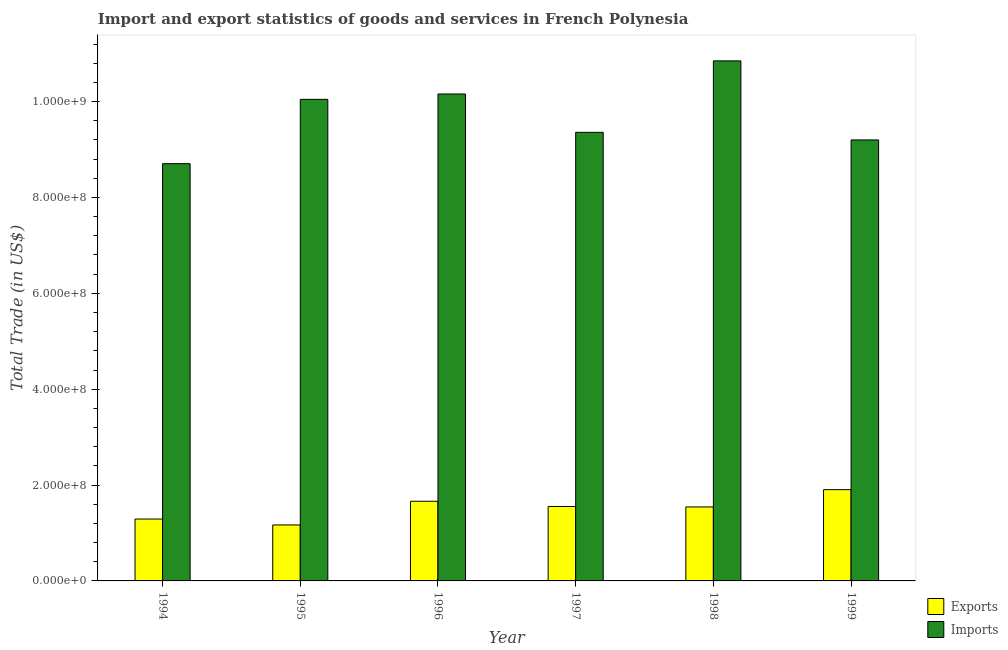How many bars are there on the 3rd tick from the left?
Make the answer very short. 2. What is the export of goods and services in 1996?
Give a very brief answer. 1.66e+08. Across all years, what is the maximum imports of goods and services?
Provide a short and direct response. 1.08e+09. Across all years, what is the minimum imports of goods and services?
Offer a very short reply. 8.70e+08. In which year was the export of goods and services minimum?
Your answer should be very brief. 1995. What is the total export of goods and services in the graph?
Offer a terse response. 9.12e+08. What is the difference between the export of goods and services in 1995 and that in 1999?
Make the answer very short. -7.37e+07. What is the difference between the imports of goods and services in 1995 and the export of goods and services in 1999?
Your answer should be very brief. 8.47e+07. What is the average export of goods and services per year?
Offer a very short reply. 1.52e+08. In the year 1996, what is the difference between the imports of goods and services and export of goods and services?
Offer a very short reply. 0. What is the ratio of the imports of goods and services in 1995 to that in 1998?
Ensure brevity in your answer.  0.93. What is the difference between the highest and the second highest imports of goods and services?
Make the answer very short. 6.91e+07. What is the difference between the highest and the lowest imports of goods and services?
Your answer should be compact. 2.14e+08. In how many years, is the imports of goods and services greater than the average imports of goods and services taken over all years?
Offer a very short reply. 3. Is the sum of the imports of goods and services in 1994 and 1997 greater than the maximum export of goods and services across all years?
Your answer should be compact. Yes. What does the 2nd bar from the left in 1996 represents?
Offer a very short reply. Imports. What does the 2nd bar from the right in 1995 represents?
Offer a very short reply. Exports. Are all the bars in the graph horizontal?
Offer a terse response. No. What is the difference between two consecutive major ticks on the Y-axis?
Make the answer very short. 2.00e+08. Does the graph contain any zero values?
Provide a succinct answer. No. Does the graph contain grids?
Your answer should be very brief. No. Where does the legend appear in the graph?
Give a very brief answer. Bottom right. How many legend labels are there?
Offer a very short reply. 2. How are the legend labels stacked?
Your answer should be very brief. Vertical. What is the title of the graph?
Provide a succinct answer. Import and export statistics of goods and services in French Polynesia. Does "Arms imports" appear as one of the legend labels in the graph?
Your response must be concise. No. What is the label or title of the Y-axis?
Offer a very short reply. Total Trade (in US$). What is the Total Trade (in US$) in Exports in 1994?
Ensure brevity in your answer.  1.29e+08. What is the Total Trade (in US$) in Imports in 1994?
Keep it short and to the point. 8.70e+08. What is the Total Trade (in US$) in Exports in 1995?
Keep it short and to the point. 1.17e+08. What is the Total Trade (in US$) of Imports in 1995?
Give a very brief answer. 1.00e+09. What is the Total Trade (in US$) in Exports in 1996?
Give a very brief answer. 1.66e+08. What is the Total Trade (in US$) in Imports in 1996?
Offer a terse response. 1.02e+09. What is the Total Trade (in US$) in Exports in 1997?
Keep it short and to the point. 1.55e+08. What is the Total Trade (in US$) in Imports in 1997?
Provide a succinct answer. 9.36e+08. What is the Total Trade (in US$) in Exports in 1998?
Your response must be concise. 1.54e+08. What is the Total Trade (in US$) in Imports in 1998?
Your response must be concise. 1.08e+09. What is the Total Trade (in US$) in Exports in 1999?
Offer a terse response. 1.90e+08. What is the Total Trade (in US$) in Imports in 1999?
Offer a very short reply. 9.20e+08. Across all years, what is the maximum Total Trade (in US$) in Exports?
Provide a short and direct response. 1.90e+08. Across all years, what is the maximum Total Trade (in US$) in Imports?
Keep it short and to the point. 1.08e+09. Across all years, what is the minimum Total Trade (in US$) of Exports?
Your response must be concise. 1.17e+08. Across all years, what is the minimum Total Trade (in US$) of Imports?
Give a very brief answer. 8.70e+08. What is the total Total Trade (in US$) in Exports in the graph?
Provide a succinct answer. 9.12e+08. What is the total Total Trade (in US$) of Imports in the graph?
Make the answer very short. 5.83e+09. What is the difference between the Total Trade (in US$) of Exports in 1994 and that in 1995?
Offer a terse response. 1.23e+07. What is the difference between the Total Trade (in US$) in Imports in 1994 and that in 1995?
Make the answer very short. -1.34e+08. What is the difference between the Total Trade (in US$) of Exports in 1994 and that in 1996?
Offer a very short reply. -3.71e+07. What is the difference between the Total Trade (in US$) of Imports in 1994 and that in 1996?
Your answer should be very brief. -1.45e+08. What is the difference between the Total Trade (in US$) in Exports in 1994 and that in 1997?
Your answer should be very brief. -2.62e+07. What is the difference between the Total Trade (in US$) in Imports in 1994 and that in 1997?
Your answer should be very brief. -6.54e+07. What is the difference between the Total Trade (in US$) of Exports in 1994 and that in 1998?
Provide a succinct answer. -2.53e+07. What is the difference between the Total Trade (in US$) of Imports in 1994 and that in 1998?
Provide a succinct answer. -2.14e+08. What is the difference between the Total Trade (in US$) in Exports in 1994 and that in 1999?
Your response must be concise. -6.13e+07. What is the difference between the Total Trade (in US$) of Imports in 1994 and that in 1999?
Your answer should be compact. -4.95e+07. What is the difference between the Total Trade (in US$) of Exports in 1995 and that in 1996?
Offer a terse response. -4.94e+07. What is the difference between the Total Trade (in US$) of Imports in 1995 and that in 1996?
Offer a terse response. -1.12e+07. What is the difference between the Total Trade (in US$) in Exports in 1995 and that in 1997?
Offer a terse response. -3.85e+07. What is the difference between the Total Trade (in US$) of Imports in 1995 and that in 1997?
Give a very brief answer. 6.88e+07. What is the difference between the Total Trade (in US$) in Exports in 1995 and that in 1998?
Offer a terse response. -3.76e+07. What is the difference between the Total Trade (in US$) of Imports in 1995 and that in 1998?
Provide a succinct answer. -8.03e+07. What is the difference between the Total Trade (in US$) in Exports in 1995 and that in 1999?
Give a very brief answer. -7.37e+07. What is the difference between the Total Trade (in US$) in Imports in 1995 and that in 1999?
Provide a succinct answer. 8.47e+07. What is the difference between the Total Trade (in US$) of Exports in 1996 and that in 1997?
Make the answer very short. 1.09e+07. What is the difference between the Total Trade (in US$) of Imports in 1996 and that in 1997?
Offer a terse response. 8.00e+07. What is the difference between the Total Trade (in US$) in Exports in 1996 and that in 1998?
Make the answer very short. 1.18e+07. What is the difference between the Total Trade (in US$) in Imports in 1996 and that in 1998?
Keep it short and to the point. -6.91e+07. What is the difference between the Total Trade (in US$) in Exports in 1996 and that in 1999?
Your answer should be very brief. -2.43e+07. What is the difference between the Total Trade (in US$) of Imports in 1996 and that in 1999?
Make the answer very short. 9.59e+07. What is the difference between the Total Trade (in US$) in Exports in 1997 and that in 1998?
Make the answer very short. 9.61e+05. What is the difference between the Total Trade (in US$) of Imports in 1997 and that in 1998?
Give a very brief answer. -1.49e+08. What is the difference between the Total Trade (in US$) of Exports in 1997 and that in 1999?
Ensure brevity in your answer.  -3.51e+07. What is the difference between the Total Trade (in US$) of Imports in 1997 and that in 1999?
Your answer should be compact. 1.59e+07. What is the difference between the Total Trade (in US$) of Exports in 1998 and that in 1999?
Your answer should be compact. -3.61e+07. What is the difference between the Total Trade (in US$) of Imports in 1998 and that in 1999?
Make the answer very short. 1.65e+08. What is the difference between the Total Trade (in US$) in Exports in 1994 and the Total Trade (in US$) in Imports in 1995?
Offer a very short reply. -8.76e+08. What is the difference between the Total Trade (in US$) in Exports in 1994 and the Total Trade (in US$) in Imports in 1996?
Give a very brief answer. -8.87e+08. What is the difference between the Total Trade (in US$) of Exports in 1994 and the Total Trade (in US$) of Imports in 1997?
Your answer should be very brief. -8.07e+08. What is the difference between the Total Trade (in US$) in Exports in 1994 and the Total Trade (in US$) in Imports in 1998?
Your answer should be very brief. -9.56e+08. What is the difference between the Total Trade (in US$) in Exports in 1994 and the Total Trade (in US$) in Imports in 1999?
Keep it short and to the point. -7.91e+08. What is the difference between the Total Trade (in US$) in Exports in 1995 and the Total Trade (in US$) in Imports in 1996?
Provide a short and direct response. -8.99e+08. What is the difference between the Total Trade (in US$) in Exports in 1995 and the Total Trade (in US$) in Imports in 1997?
Give a very brief answer. -8.19e+08. What is the difference between the Total Trade (in US$) in Exports in 1995 and the Total Trade (in US$) in Imports in 1998?
Offer a terse response. -9.68e+08. What is the difference between the Total Trade (in US$) of Exports in 1995 and the Total Trade (in US$) of Imports in 1999?
Your response must be concise. -8.03e+08. What is the difference between the Total Trade (in US$) in Exports in 1996 and the Total Trade (in US$) in Imports in 1997?
Offer a very short reply. -7.70e+08. What is the difference between the Total Trade (in US$) in Exports in 1996 and the Total Trade (in US$) in Imports in 1998?
Ensure brevity in your answer.  -9.19e+08. What is the difference between the Total Trade (in US$) in Exports in 1996 and the Total Trade (in US$) in Imports in 1999?
Keep it short and to the point. -7.54e+08. What is the difference between the Total Trade (in US$) of Exports in 1997 and the Total Trade (in US$) of Imports in 1998?
Give a very brief answer. -9.30e+08. What is the difference between the Total Trade (in US$) in Exports in 1997 and the Total Trade (in US$) in Imports in 1999?
Provide a succinct answer. -7.65e+08. What is the difference between the Total Trade (in US$) of Exports in 1998 and the Total Trade (in US$) of Imports in 1999?
Provide a succinct answer. -7.66e+08. What is the average Total Trade (in US$) in Exports per year?
Offer a very short reply. 1.52e+08. What is the average Total Trade (in US$) in Imports per year?
Your answer should be very brief. 9.72e+08. In the year 1994, what is the difference between the Total Trade (in US$) in Exports and Total Trade (in US$) in Imports?
Offer a terse response. -7.41e+08. In the year 1995, what is the difference between the Total Trade (in US$) of Exports and Total Trade (in US$) of Imports?
Offer a very short reply. -8.88e+08. In the year 1996, what is the difference between the Total Trade (in US$) of Exports and Total Trade (in US$) of Imports?
Your response must be concise. -8.50e+08. In the year 1997, what is the difference between the Total Trade (in US$) of Exports and Total Trade (in US$) of Imports?
Provide a short and direct response. -7.81e+08. In the year 1998, what is the difference between the Total Trade (in US$) of Exports and Total Trade (in US$) of Imports?
Offer a very short reply. -9.31e+08. In the year 1999, what is the difference between the Total Trade (in US$) in Exports and Total Trade (in US$) in Imports?
Make the answer very short. -7.30e+08. What is the ratio of the Total Trade (in US$) in Exports in 1994 to that in 1995?
Make the answer very short. 1.11. What is the ratio of the Total Trade (in US$) in Imports in 1994 to that in 1995?
Offer a terse response. 0.87. What is the ratio of the Total Trade (in US$) of Exports in 1994 to that in 1996?
Give a very brief answer. 0.78. What is the ratio of the Total Trade (in US$) in Imports in 1994 to that in 1996?
Your response must be concise. 0.86. What is the ratio of the Total Trade (in US$) in Exports in 1994 to that in 1997?
Offer a very short reply. 0.83. What is the ratio of the Total Trade (in US$) of Imports in 1994 to that in 1997?
Offer a terse response. 0.93. What is the ratio of the Total Trade (in US$) in Exports in 1994 to that in 1998?
Your answer should be very brief. 0.84. What is the ratio of the Total Trade (in US$) in Imports in 1994 to that in 1998?
Your answer should be compact. 0.8. What is the ratio of the Total Trade (in US$) of Exports in 1994 to that in 1999?
Keep it short and to the point. 0.68. What is the ratio of the Total Trade (in US$) in Imports in 1994 to that in 1999?
Give a very brief answer. 0.95. What is the ratio of the Total Trade (in US$) in Exports in 1995 to that in 1996?
Ensure brevity in your answer.  0.7. What is the ratio of the Total Trade (in US$) in Exports in 1995 to that in 1997?
Offer a very short reply. 0.75. What is the ratio of the Total Trade (in US$) of Imports in 1995 to that in 1997?
Your response must be concise. 1.07. What is the ratio of the Total Trade (in US$) of Exports in 1995 to that in 1998?
Keep it short and to the point. 0.76. What is the ratio of the Total Trade (in US$) in Imports in 1995 to that in 1998?
Ensure brevity in your answer.  0.93. What is the ratio of the Total Trade (in US$) of Exports in 1995 to that in 1999?
Offer a terse response. 0.61. What is the ratio of the Total Trade (in US$) in Imports in 1995 to that in 1999?
Make the answer very short. 1.09. What is the ratio of the Total Trade (in US$) in Exports in 1996 to that in 1997?
Make the answer very short. 1.07. What is the ratio of the Total Trade (in US$) in Imports in 1996 to that in 1997?
Your answer should be compact. 1.09. What is the ratio of the Total Trade (in US$) of Exports in 1996 to that in 1998?
Your answer should be compact. 1.08. What is the ratio of the Total Trade (in US$) of Imports in 1996 to that in 1998?
Your answer should be very brief. 0.94. What is the ratio of the Total Trade (in US$) in Exports in 1996 to that in 1999?
Your response must be concise. 0.87. What is the ratio of the Total Trade (in US$) of Imports in 1996 to that in 1999?
Provide a succinct answer. 1.1. What is the ratio of the Total Trade (in US$) of Exports in 1997 to that in 1998?
Your answer should be compact. 1.01. What is the ratio of the Total Trade (in US$) in Imports in 1997 to that in 1998?
Your answer should be compact. 0.86. What is the ratio of the Total Trade (in US$) in Exports in 1997 to that in 1999?
Ensure brevity in your answer.  0.82. What is the ratio of the Total Trade (in US$) in Imports in 1997 to that in 1999?
Make the answer very short. 1.02. What is the ratio of the Total Trade (in US$) in Exports in 1998 to that in 1999?
Provide a short and direct response. 0.81. What is the ratio of the Total Trade (in US$) in Imports in 1998 to that in 1999?
Give a very brief answer. 1.18. What is the difference between the highest and the second highest Total Trade (in US$) in Exports?
Provide a succinct answer. 2.43e+07. What is the difference between the highest and the second highest Total Trade (in US$) in Imports?
Offer a terse response. 6.91e+07. What is the difference between the highest and the lowest Total Trade (in US$) of Exports?
Give a very brief answer. 7.37e+07. What is the difference between the highest and the lowest Total Trade (in US$) in Imports?
Give a very brief answer. 2.14e+08. 